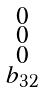<formula> <loc_0><loc_0><loc_500><loc_500>\begin{smallmatrix} 0 \\ 0 \\ 0 \\ b _ { 3 2 } \\ \end{smallmatrix}</formula> 